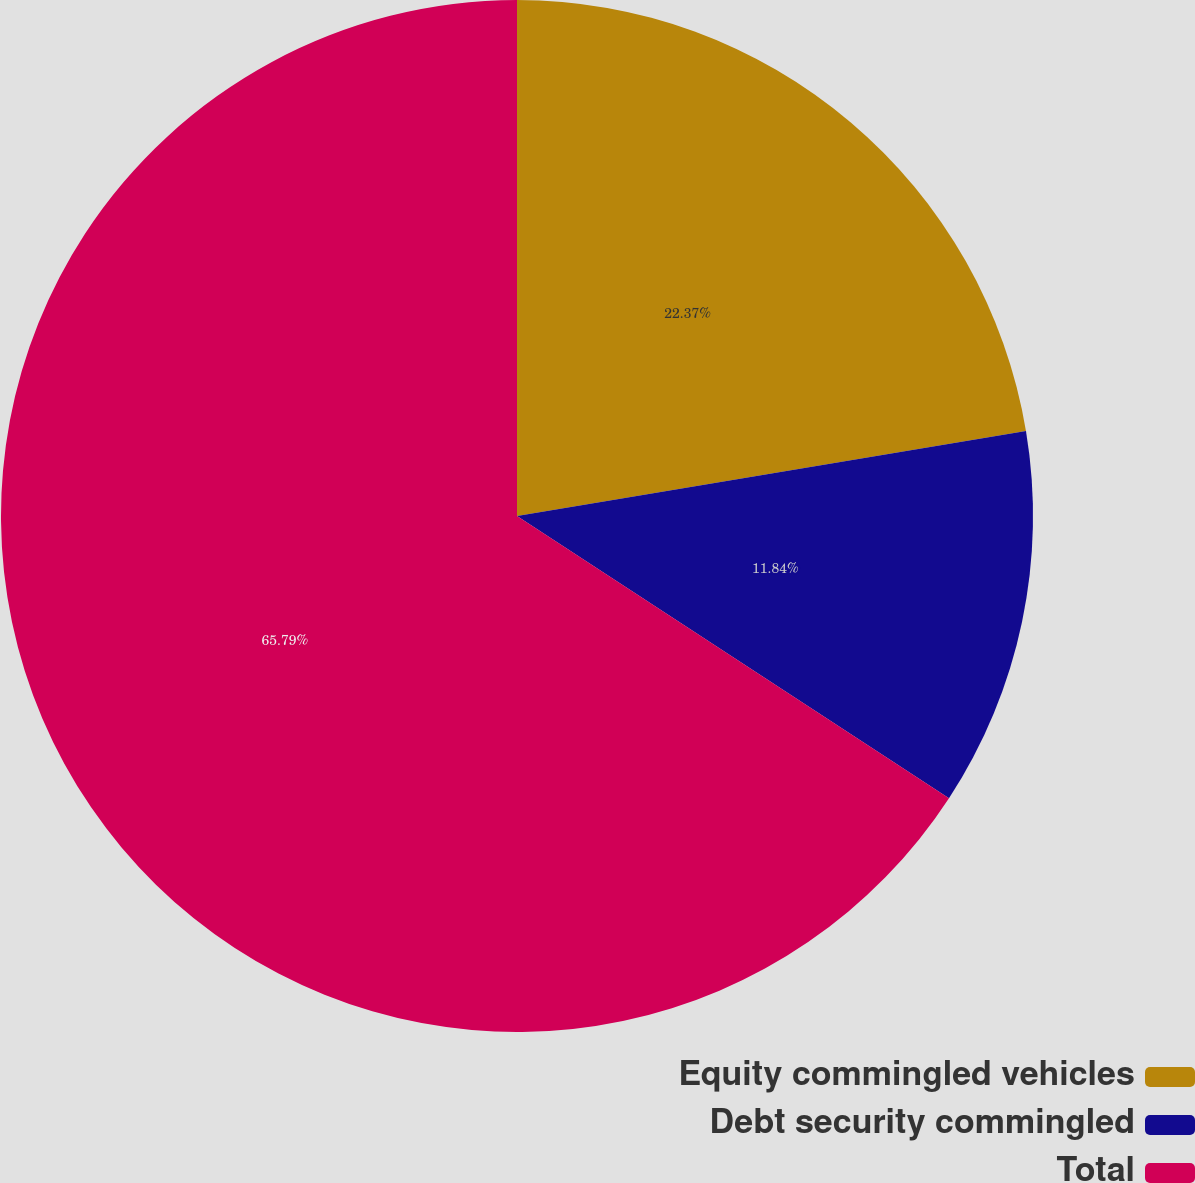Convert chart. <chart><loc_0><loc_0><loc_500><loc_500><pie_chart><fcel>Equity commingled vehicles<fcel>Debt security commingled<fcel>Total<nl><fcel>22.37%<fcel>11.84%<fcel>65.79%<nl></chart> 